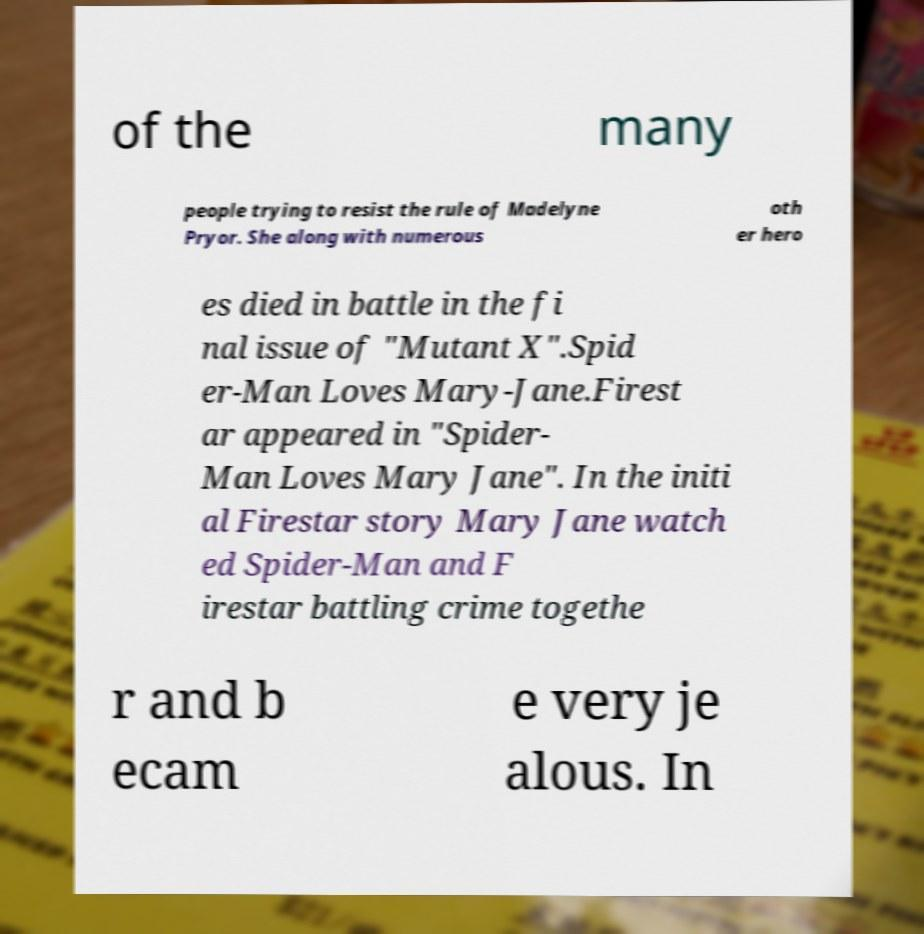Could you extract and type out the text from this image? of the many people trying to resist the rule of Madelyne Pryor. She along with numerous oth er hero es died in battle in the fi nal issue of "Mutant X".Spid er-Man Loves Mary-Jane.Firest ar appeared in "Spider- Man Loves Mary Jane". In the initi al Firestar story Mary Jane watch ed Spider-Man and F irestar battling crime togethe r and b ecam e very je alous. In 